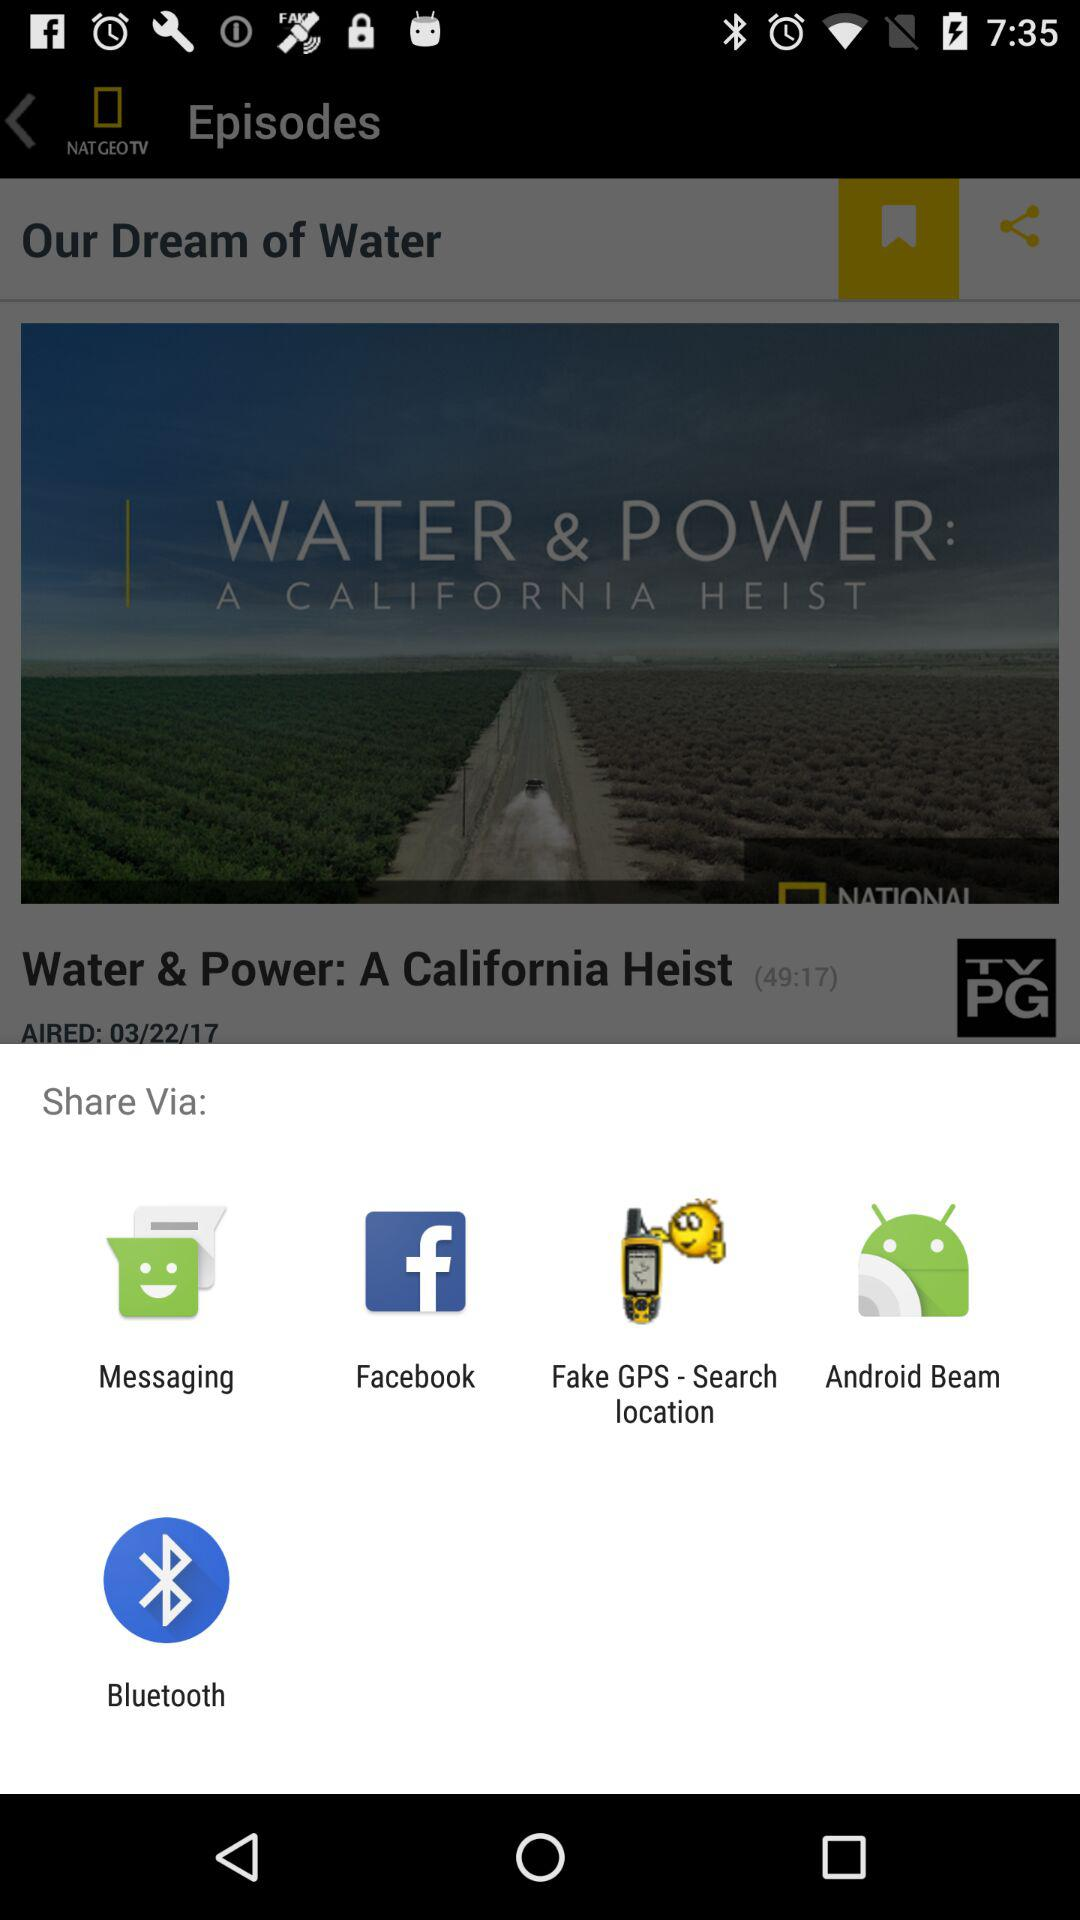What is the name of the application? The name of the application is "NAT GEO TV". 